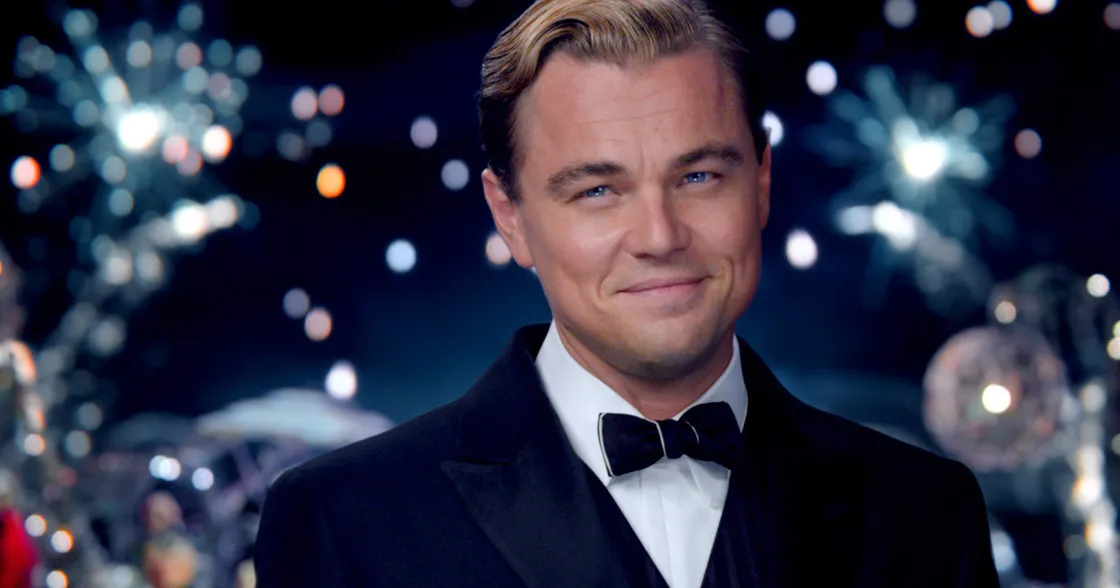What thoughts might be going through the character’s mind as he looks into the camera? The character might be reflecting on the success of the event and the joy it has brought to the attendees. His slight smile indicates a sense of satisfaction and pride, perhaps even nostalgia for a bygone era of elegance and celebration. He could be savoring this moment, feeling accomplished and content amidst the splendor. Create a dialogue where the character interacts with another guest at the party, one casual and one more in-depth. Casual Dialogue: 
Guest: "This party is absolutely stunning! The fireworks are spectacular." 
Character: "Thank you. I'm glad you're enjoying yourself. It's a special night indeed." In-depth Dialogue: 
Guest: "This evening is truly magical. I've never seen fireworks like these before." 
Character: "I'm thrilled you feel that way. Each display is carefully planned to evoke a sense of wonder and joy. It's about creating memories that last a lifetime." 
Guest: "You've certainly succeeded. This night will be remembered for years to come." 
Character: "That's the goal. In these moments, we find a connection, a shared experience that transcends the ordinary. It's what makes life beautiful." 